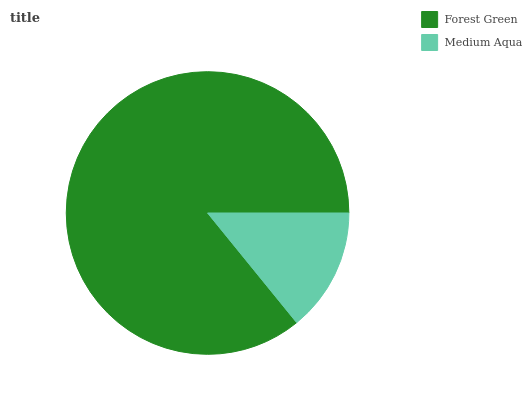Is Medium Aqua the minimum?
Answer yes or no. Yes. Is Forest Green the maximum?
Answer yes or no. Yes. Is Medium Aqua the maximum?
Answer yes or no. No. Is Forest Green greater than Medium Aqua?
Answer yes or no. Yes. Is Medium Aqua less than Forest Green?
Answer yes or no. Yes. Is Medium Aqua greater than Forest Green?
Answer yes or no. No. Is Forest Green less than Medium Aqua?
Answer yes or no. No. Is Forest Green the high median?
Answer yes or no. Yes. Is Medium Aqua the low median?
Answer yes or no. Yes. Is Medium Aqua the high median?
Answer yes or no. No. Is Forest Green the low median?
Answer yes or no. No. 